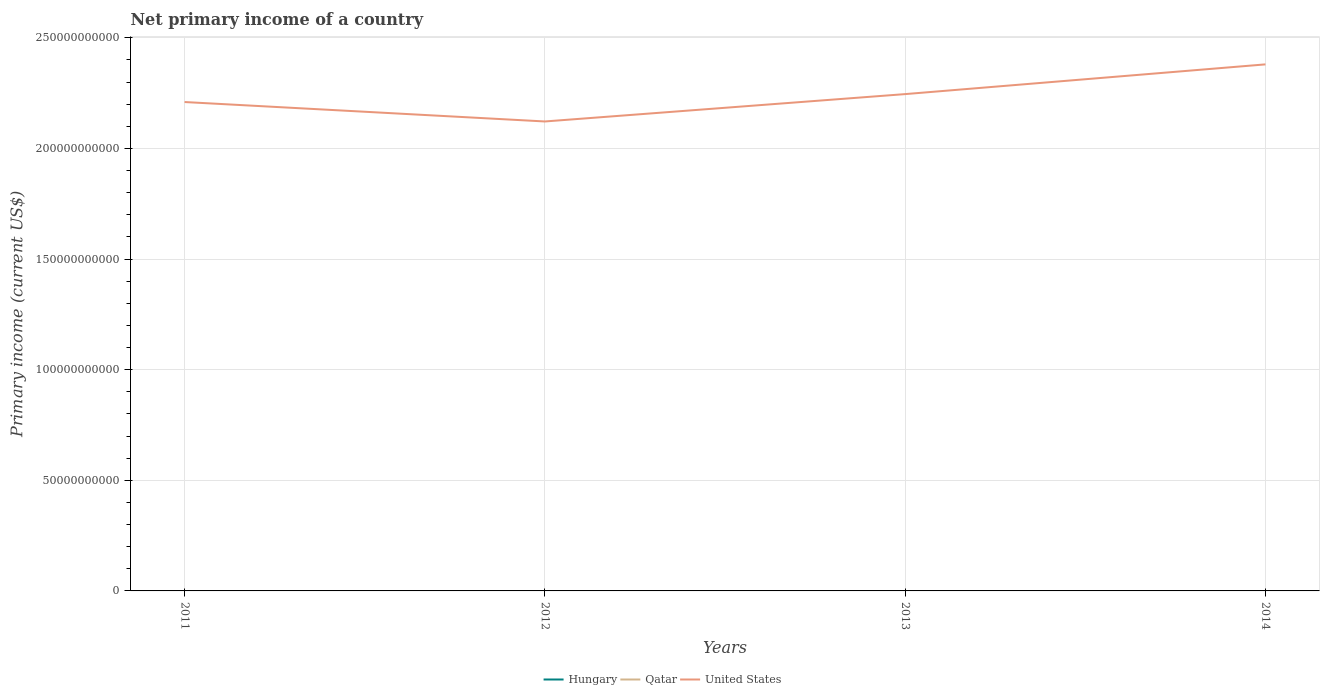How many different coloured lines are there?
Give a very brief answer. 1. Does the line corresponding to Qatar intersect with the line corresponding to Hungary?
Give a very brief answer. No. Is the number of lines equal to the number of legend labels?
Your answer should be very brief. No. What is the total primary income in United States in the graph?
Provide a succinct answer. -1.24e+1. What is the difference between the highest and the second highest primary income in United States?
Your response must be concise. 2.58e+1. How many lines are there?
Offer a very short reply. 1. How many years are there in the graph?
Provide a short and direct response. 4. Does the graph contain any zero values?
Your answer should be compact. Yes. Where does the legend appear in the graph?
Your answer should be very brief. Bottom center. What is the title of the graph?
Provide a short and direct response. Net primary income of a country. Does "OECD members" appear as one of the legend labels in the graph?
Your answer should be compact. No. What is the label or title of the Y-axis?
Your response must be concise. Primary income (current US$). What is the Primary income (current US$) in Hungary in 2011?
Ensure brevity in your answer.  0. What is the Primary income (current US$) of United States in 2011?
Give a very brief answer. 2.21e+11. What is the Primary income (current US$) in Qatar in 2012?
Ensure brevity in your answer.  0. What is the Primary income (current US$) of United States in 2012?
Your response must be concise. 2.12e+11. What is the Primary income (current US$) in Hungary in 2013?
Provide a short and direct response. 0. What is the Primary income (current US$) of United States in 2013?
Make the answer very short. 2.25e+11. What is the Primary income (current US$) in Hungary in 2014?
Offer a very short reply. 0. What is the Primary income (current US$) in Qatar in 2014?
Ensure brevity in your answer.  0. What is the Primary income (current US$) of United States in 2014?
Your answer should be compact. 2.38e+11. Across all years, what is the maximum Primary income (current US$) of United States?
Give a very brief answer. 2.38e+11. Across all years, what is the minimum Primary income (current US$) in United States?
Make the answer very short. 2.12e+11. What is the total Primary income (current US$) in Hungary in the graph?
Make the answer very short. 0. What is the total Primary income (current US$) in United States in the graph?
Offer a very short reply. 8.96e+11. What is the difference between the Primary income (current US$) of United States in 2011 and that in 2012?
Provide a short and direct response. 8.78e+09. What is the difference between the Primary income (current US$) of United States in 2011 and that in 2013?
Your response must be concise. -3.58e+09. What is the difference between the Primary income (current US$) of United States in 2011 and that in 2014?
Give a very brief answer. -1.70e+1. What is the difference between the Primary income (current US$) of United States in 2012 and that in 2013?
Make the answer very short. -1.24e+1. What is the difference between the Primary income (current US$) in United States in 2012 and that in 2014?
Keep it short and to the point. -2.58e+1. What is the difference between the Primary income (current US$) of United States in 2013 and that in 2014?
Offer a terse response. -1.34e+1. What is the average Primary income (current US$) of Qatar per year?
Make the answer very short. 0. What is the average Primary income (current US$) of United States per year?
Provide a short and direct response. 2.24e+11. What is the ratio of the Primary income (current US$) of United States in 2011 to that in 2012?
Offer a very short reply. 1.04. What is the ratio of the Primary income (current US$) in United States in 2011 to that in 2013?
Your answer should be compact. 0.98. What is the ratio of the Primary income (current US$) of United States in 2011 to that in 2014?
Make the answer very short. 0.93. What is the ratio of the Primary income (current US$) of United States in 2012 to that in 2013?
Offer a very short reply. 0.94. What is the ratio of the Primary income (current US$) in United States in 2012 to that in 2014?
Keep it short and to the point. 0.89. What is the ratio of the Primary income (current US$) of United States in 2013 to that in 2014?
Keep it short and to the point. 0.94. What is the difference between the highest and the second highest Primary income (current US$) in United States?
Give a very brief answer. 1.34e+1. What is the difference between the highest and the lowest Primary income (current US$) in United States?
Give a very brief answer. 2.58e+1. 